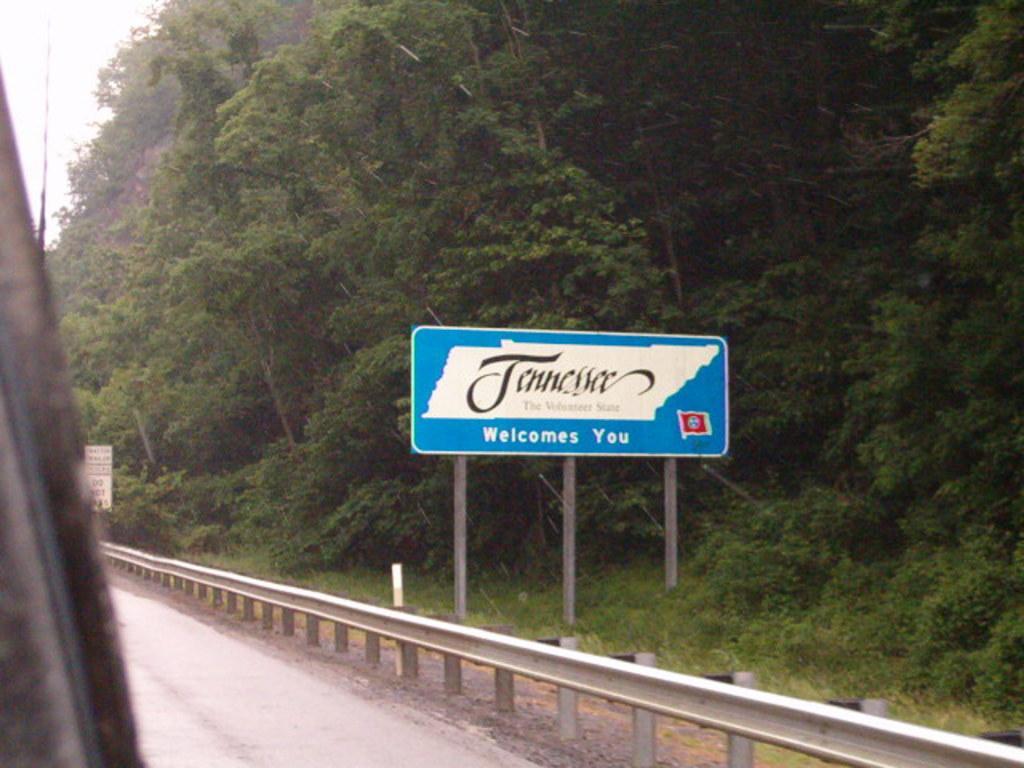Describe this image in one or two sentences. There is a road. Near to the road there is fencing. Also there is a board with poles. Also something is written on that. And there are trees. 